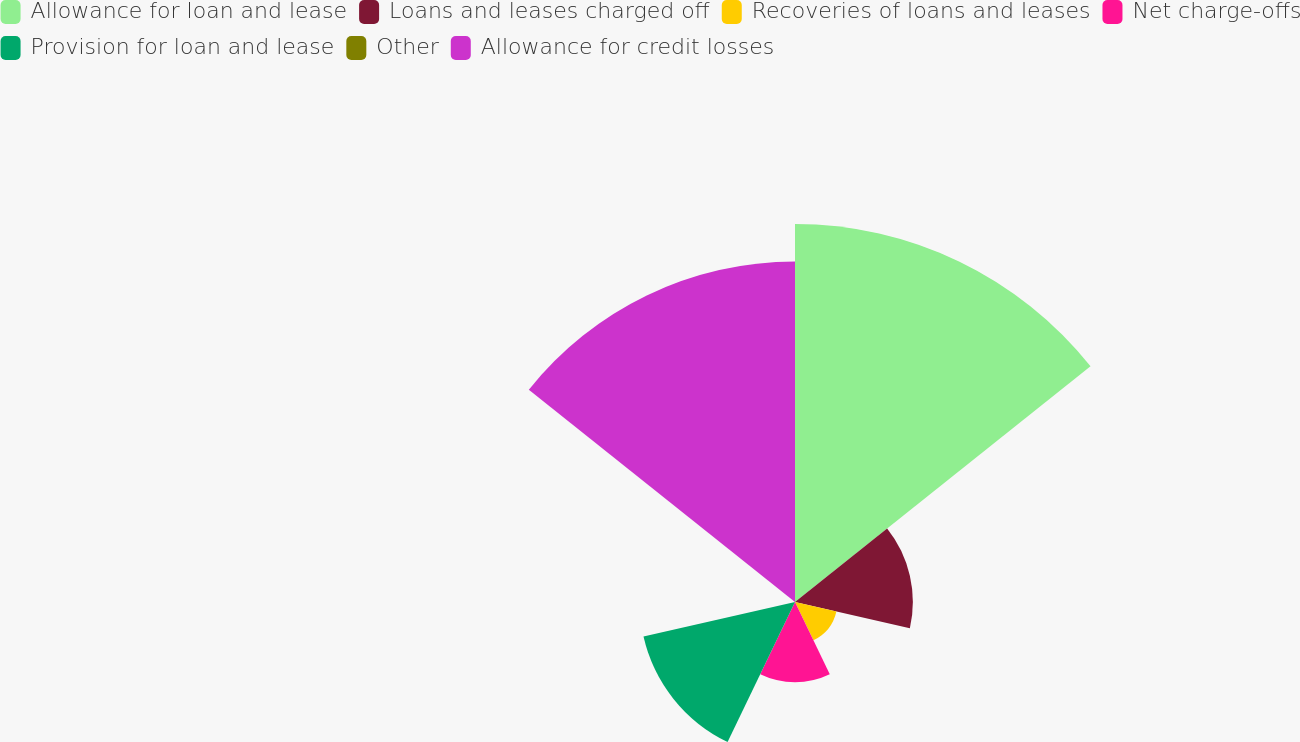<chart> <loc_0><loc_0><loc_500><loc_500><pie_chart><fcel>Allowance for loan and lease<fcel>Loans and leases charged off<fcel>Recoveries of loans and leases<fcel>Net charge-offs<fcel>Provision for loan and lease<fcel>Other<fcel>Allowance for credit losses<nl><fcel>33.91%<fcel>10.57%<fcel>3.81%<fcel>7.19%<fcel>13.94%<fcel>0.03%<fcel>30.54%<nl></chart> 